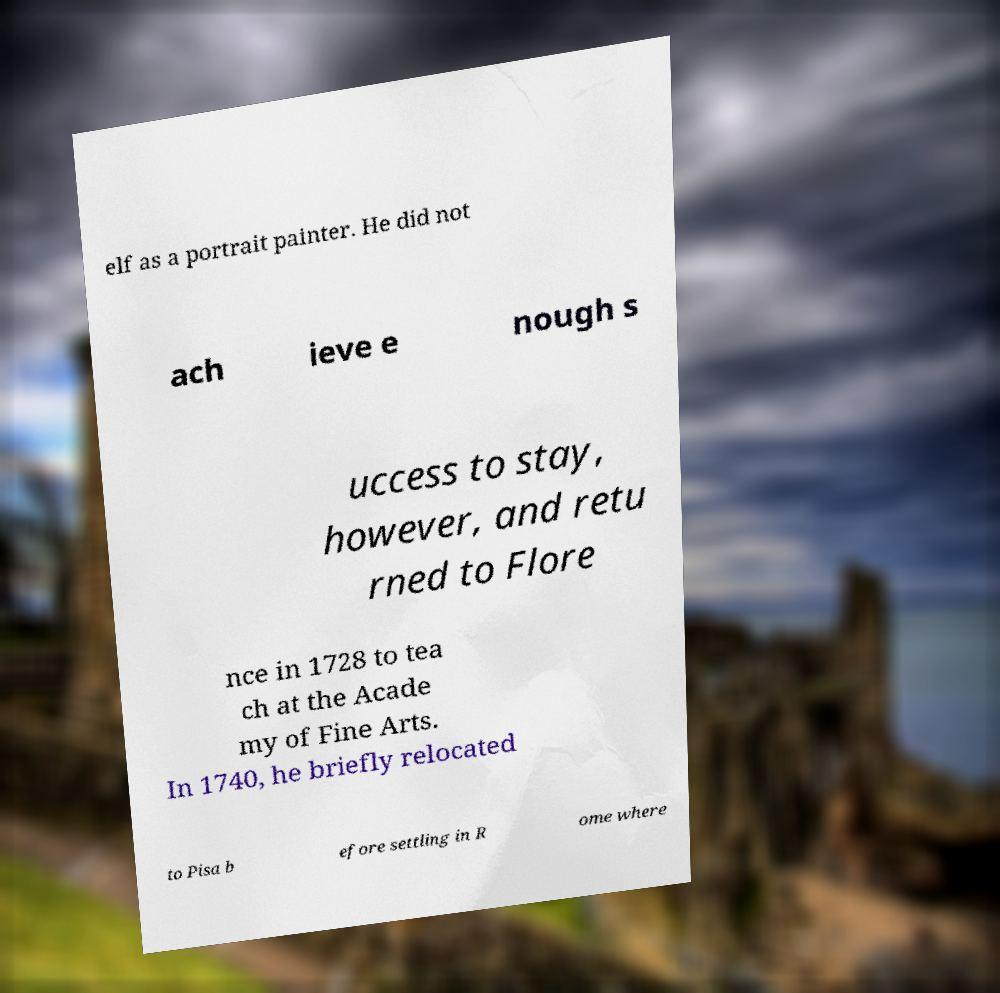Can you read and provide the text displayed in the image?This photo seems to have some interesting text. Can you extract and type it out for me? elf as a portrait painter. He did not ach ieve e nough s uccess to stay, however, and retu rned to Flore nce in 1728 to tea ch at the Acade my of Fine Arts. In 1740, he briefly relocated to Pisa b efore settling in R ome where 